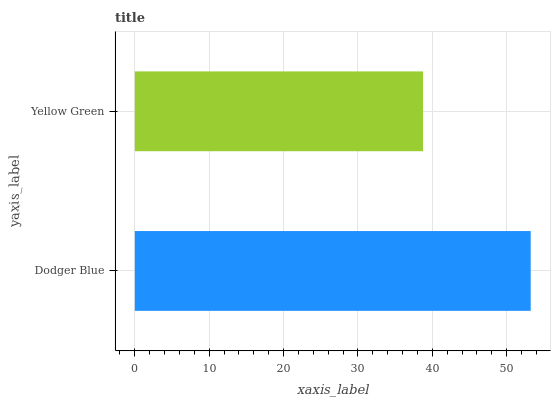Is Yellow Green the minimum?
Answer yes or no. Yes. Is Dodger Blue the maximum?
Answer yes or no. Yes. Is Yellow Green the maximum?
Answer yes or no. No. Is Dodger Blue greater than Yellow Green?
Answer yes or no. Yes. Is Yellow Green less than Dodger Blue?
Answer yes or no. Yes. Is Yellow Green greater than Dodger Blue?
Answer yes or no. No. Is Dodger Blue less than Yellow Green?
Answer yes or no. No. Is Dodger Blue the high median?
Answer yes or no. Yes. Is Yellow Green the low median?
Answer yes or no. Yes. Is Yellow Green the high median?
Answer yes or no. No. Is Dodger Blue the low median?
Answer yes or no. No. 